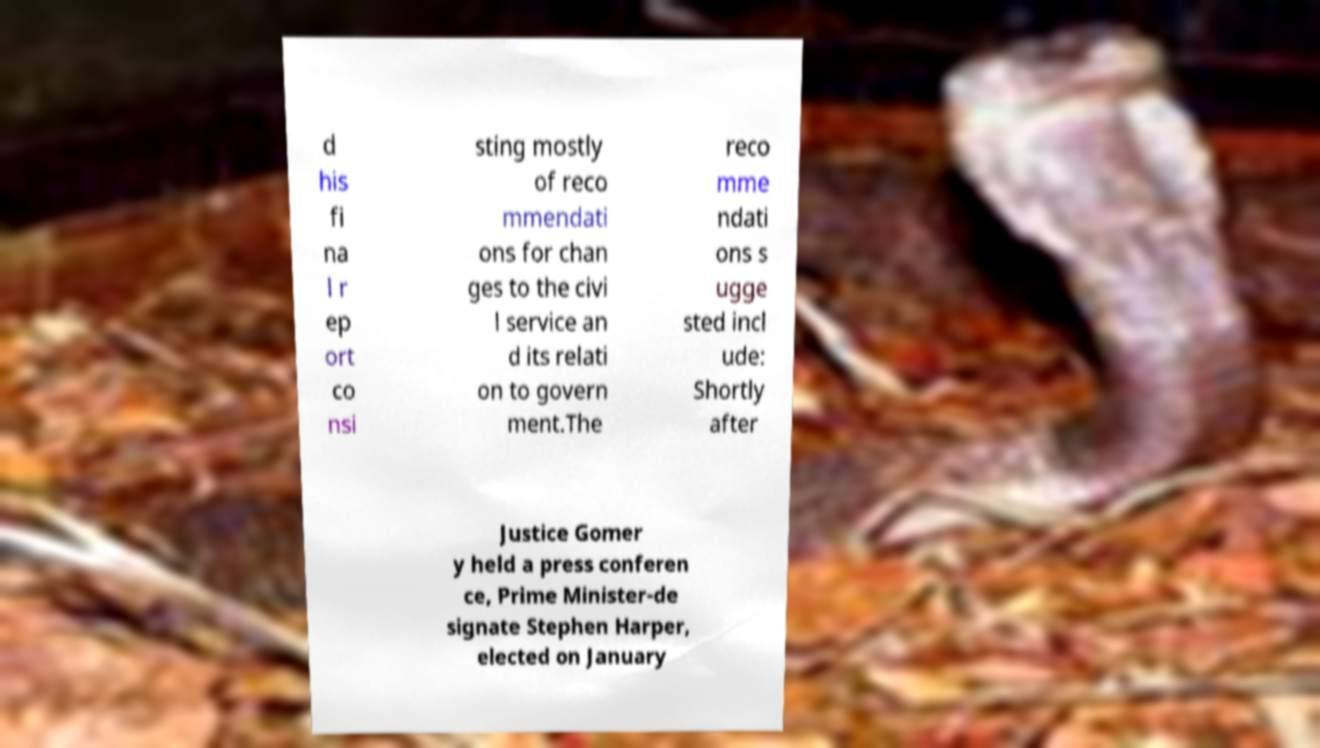Please identify and transcribe the text found in this image. d his fi na l r ep ort co nsi sting mostly of reco mmendati ons for chan ges to the civi l service an d its relati on to govern ment.The reco mme ndati ons s ugge sted incl ude: Shortly after Justice Gomer y held a press conferen ce, Prime Minister-de signate Stephen Harper, elected on January 